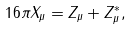<formula> <loc_0><loc_0><loc_500><loc_500>1 6 \pi X _ { \mu } = Z _ { \mu } + Z _ { \mu } ^ { \ast } ,</formula> 